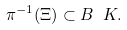<formula> <loc_0><loc_0><loc_500><loc_500>\pi ^ { - 1 } ( \Xi ) \subset B \ K .</formula> 